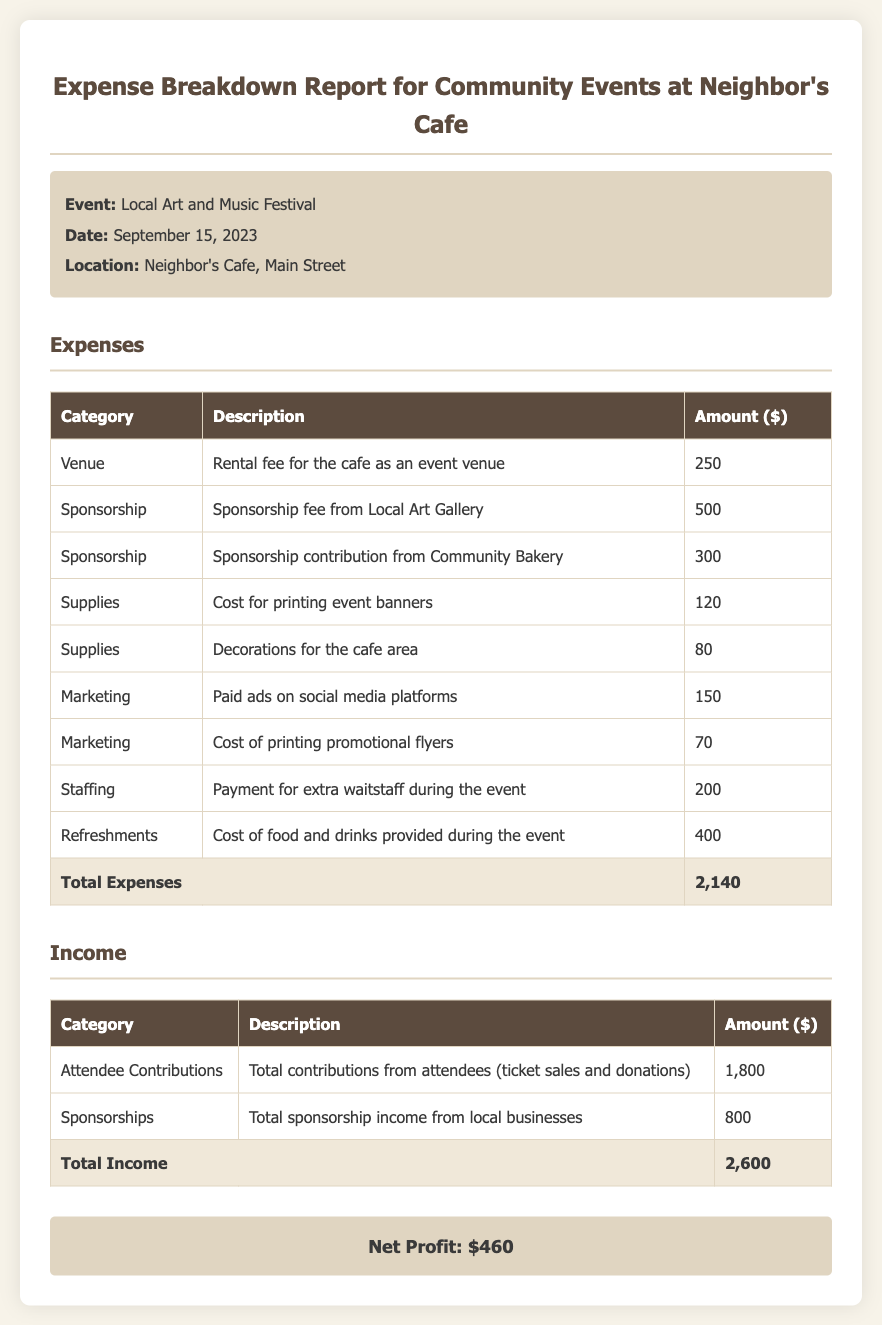What is the date of the event? The event date is stated in the document as September 15, 2023.
Answer: September 15, 2023 What was the total amount spent on refreshments? The document lists the cost of food and drinks provided during the event as $400.
Answer: $400 Who sponsored the event? The document mentions two sponsors: Local Art Gallery and Community Bakery, providing a total of $800.
Answer: Local Art Gallery, Community Bakery What was the total expense reported? The total expenses calculated from various categories is displayed as $2,140 in the document.
Answer: $2,140 What is the net profit from the event? The net profit is explicitly stated in the document as $460, derived from the income and expenses.
Answer: $460 Which category had the highest expense? The highest individual expense category is Refreshments with a cost of $400.
Answer: Refreshments What is the total income generated from the event? The total income is summed in the document as $2,600 from attendee contributions and sponsorships combined.
Answer: $2,600 What percentage of total expenses was covered by attendee contributions? The attendee contributions amount to $1,800 and represent approximately 84.03% of the total expenses of $2,140.
Answer: 84.03% How many categories are listed under expenses? The document lists a total of 7 distinct categories under expenses including Venue, Sponsorship, Supplies, Marketing, Staffing, and Refreshments.
Answer: 7 